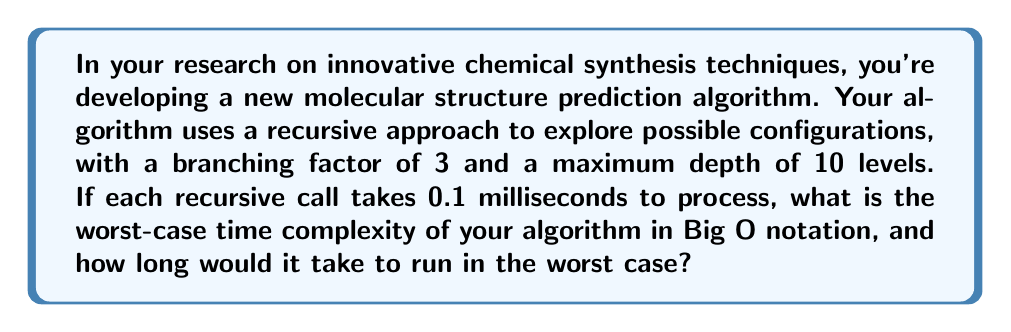Provide a solution to this math problem. To solve this problem, we need to follow these steps:

1. Determine the number of nodes in the recursion tree:
   The algorithm has a branching factor of 3 and a maximum depth of 10 levels. This forms a complete ternary tree of depth 10. The number of nodes in such a tree is given by the formula:

   $$N = \frac{3^{d+1} - 1}{2}$$

   Where $d$ is the depth of the tree. Substituting $d = 10$:

   $$N = \frac{3^{11} - 1}{2} = 88,573$$

2. Calculate the time complexity:
   The time complexity in Big O notation is $O(3^d)$ or $O(3^{10})$ in this case, as we're dealing with a complete ternary tree of depth 10.

3. Calculate the worst-case running time:
   Each node takes 0.1 milliseconds to process. So the total time is:

   $$T = 88,573 \times 0.1 \text{ ms} = 8,857.3 \text{ ms} \approx 8.86 \text{ seconds}$$

Thus, in the worst case, the algorithm would explore all possible configurations, visiting each of the 88,573 nodes in the recursion tree.
Answer: The worst-case time complexity is $O(3^{10})$, and the algorithm would take approximately 8.86 seconds to run in the worst case. 